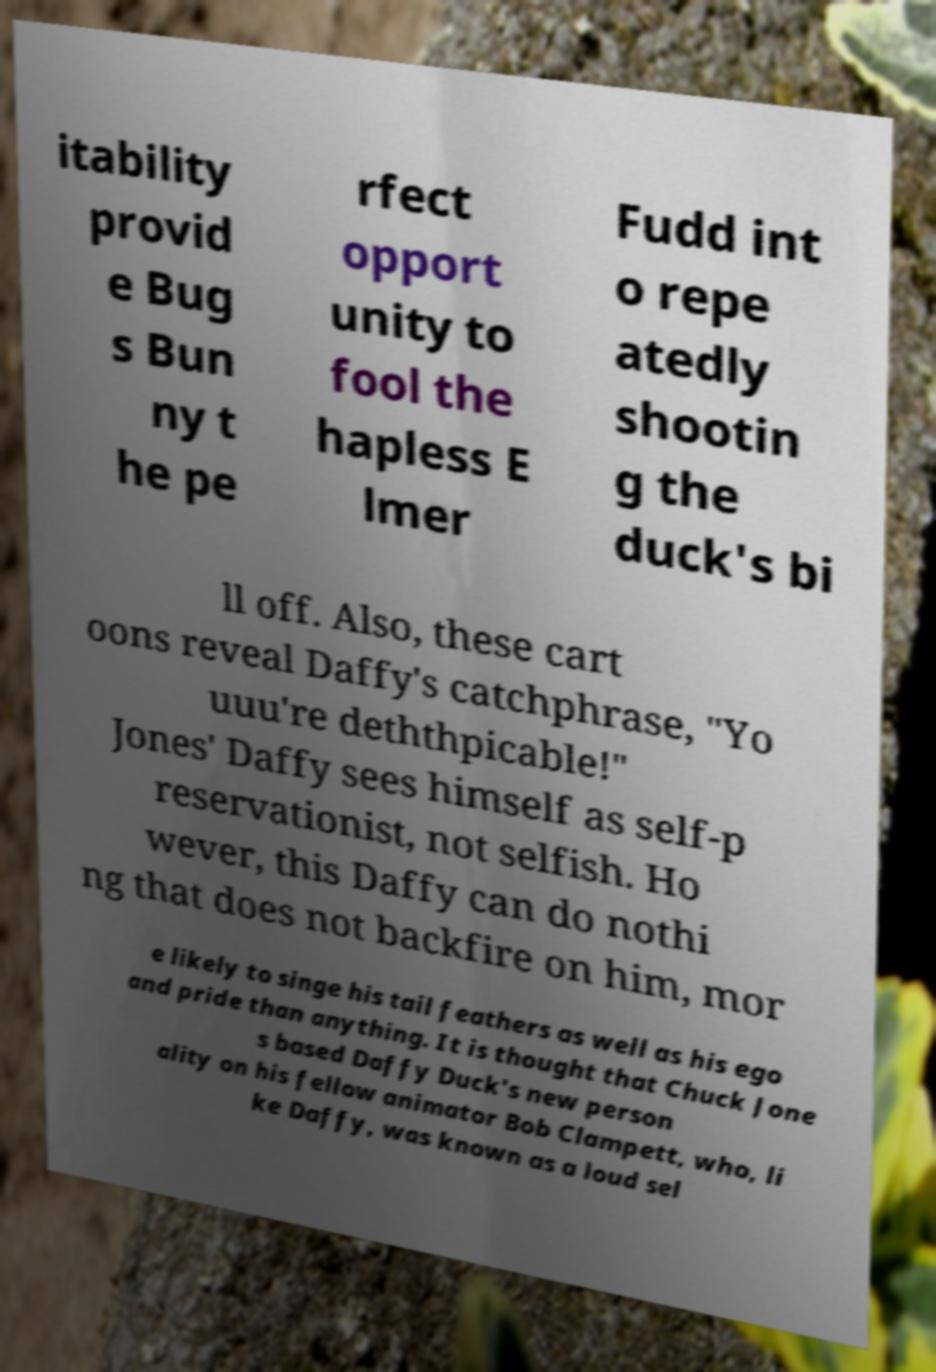I need the written content from this picture converted into text. Can you do that? itability provid e Bug s Bun ny t he pe rfect opport unity to fool the hapless E lmer Fudd int o repe atedly shootin g the duck's bi ll off. Also, these cart oons reveal Daffy's catchphrase, "Yo uuu're deththpicable!" Jones' Daffy sees himself as self-p reservationist, not selfish. Ho wever, this Daffy can do nothi ng that does not backfire on him, mor e likely to singe his tail feathers as well as his ego and pride than anything. It is thought that Chuck Jone s based Daffy Duck's new person ality on his fellow animator Bob Clampett, who, li ke Daffy, was known as a loud sel 